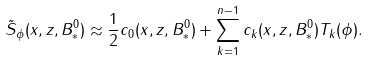<formula> <loc_0><loc_0><loc_500><loc_500>\tilde { S } _ { \phi } ( x , z , B _ { * } ^ { 0 } ) \approx \frac { 1 } { 2 } c _ { 0 } ( x , z , B _ { * } ^ { 0 } ) + \sum _ { k = 1 } ^ { n - 1 } c _ { k } ( x , z , B _ { * } ^ { 0 } ) T _ { k } ( \phi ) .</formula> 